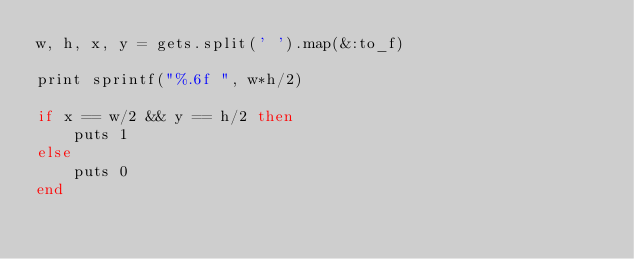<code> <loc_0><loc_0><loc_500><loc_500><_Ruby_>w, h, x, y = gets.split(' ').map(&:to_f)

print sprintf("%.6f ", w*h/2)

if x == w/2 && y == h/2 then
    puts 1
else
    puts 0
end</code> 